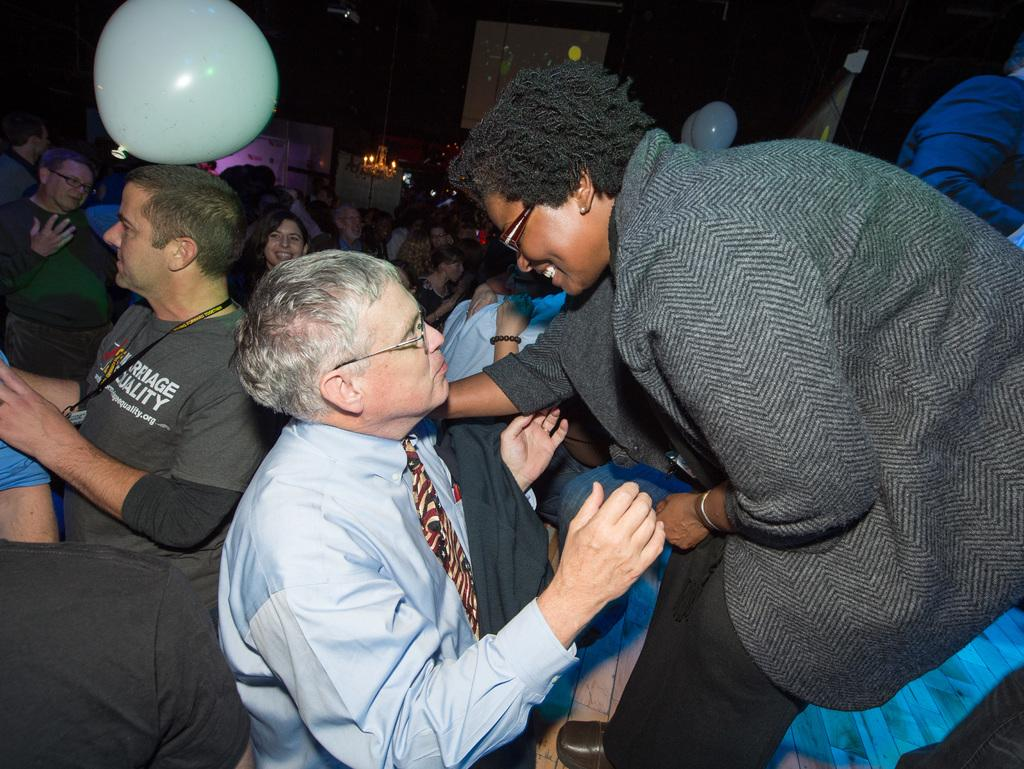What is happening in the image? There are people standing in the image. What can be seen in the background of the image? There is a screen, a balloon, a light, and a banner in the background of the image. Is there a dog feeling ashamed in the cemetery in the image? There is no dog or cemetery present in the image. 